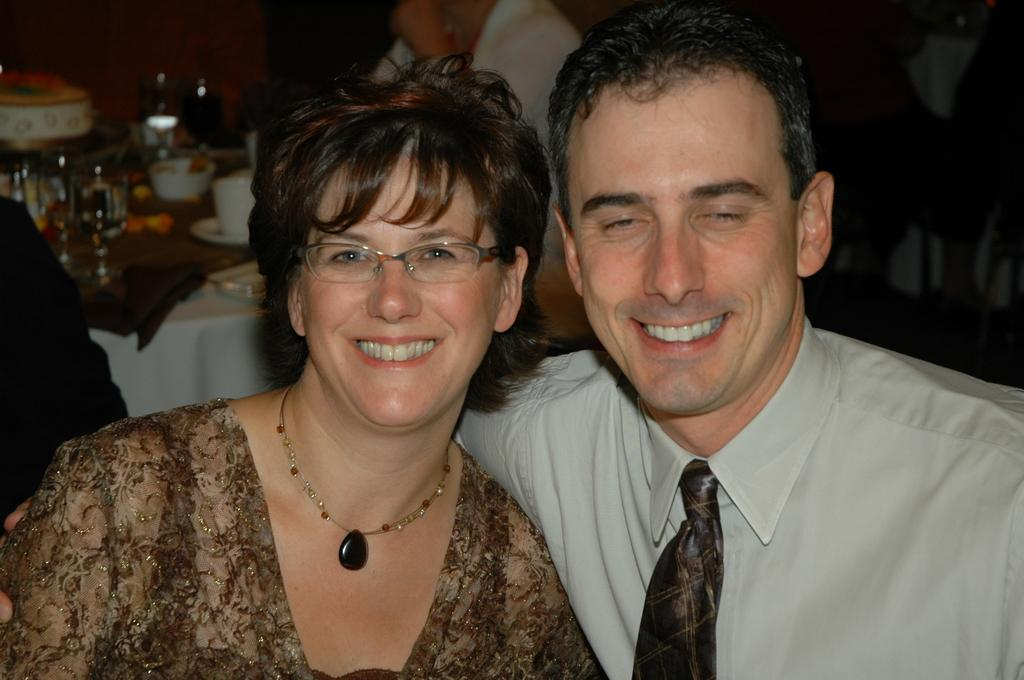What are the people in the image doing? The people in the image are sitting. What can be seen in the background of the image? There is a table in the background of the image. What items are on the table? There are glasses, a bowl, and other objects on the table. What type of finger can be seen holding the bowl in the image? There is no finger holding the bowl in the image; it is not mentioned in the provided facts. 